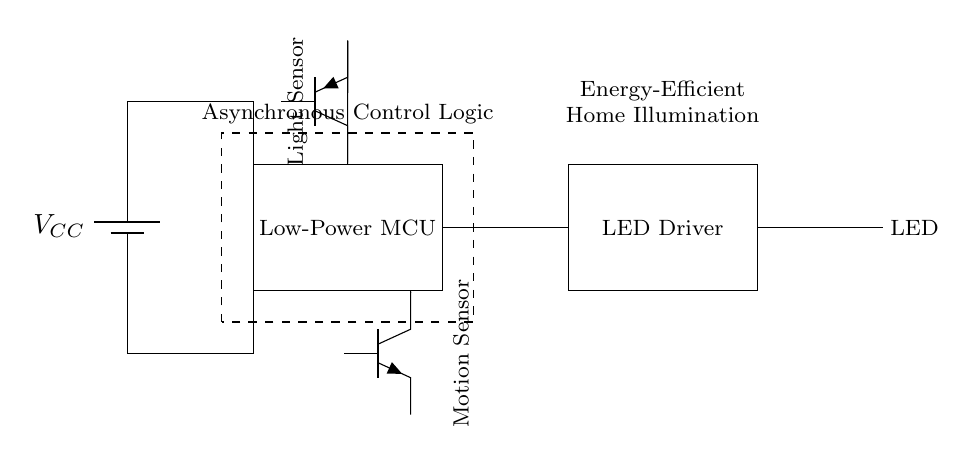What is the main power supply voltage? The main power supply voltage is indicated next to the battery symbol in the circuit diagram. Here, it is labeled as VCC.
Answer: VCC What components are included in the asynchronous lighting controller? The circuit diagram includes a low-power microcontroller, an LED driver, an LED, a light sensor, and a motion sensor. Identifying these elements provides a clear understanding of the components used.
Answer: Low-Power MCU, LED Driver, LED, Light Sensor, Motion Sensor Which component is responsible for controlling the LED? The LED driver is specifically responsible for controlling the LED, as indicated by its placement in the circuit and common functions associated with LED drivers.
Answer: LED Driver What type of sensors are included in the circuit? The circuit includes a light sensor and a motion sensor, each represented in the diagram by their respective symbols. This provides insight into the environmental interaction capabilities of the system.
Answer: Light Sensor, Motion Sensor How is the control logic described in this circuit? The control logic is described as 'Asynchronous Control Logic', which is indicated by the dashed rectangle encompassing the low-power MCU and the surrounding components. This signifies that the control feedback does not rely on a constant clock signal.
Answer: Asynchronous Control Logic What is the primary purpose of this circuit? The primary purpose of this circuit is to provide energy-efficient home illumination, as stated in the note within the diagram. It focuses on using low power for lighting when necessary.
Answer: Energy-Efficient Home Illumination 